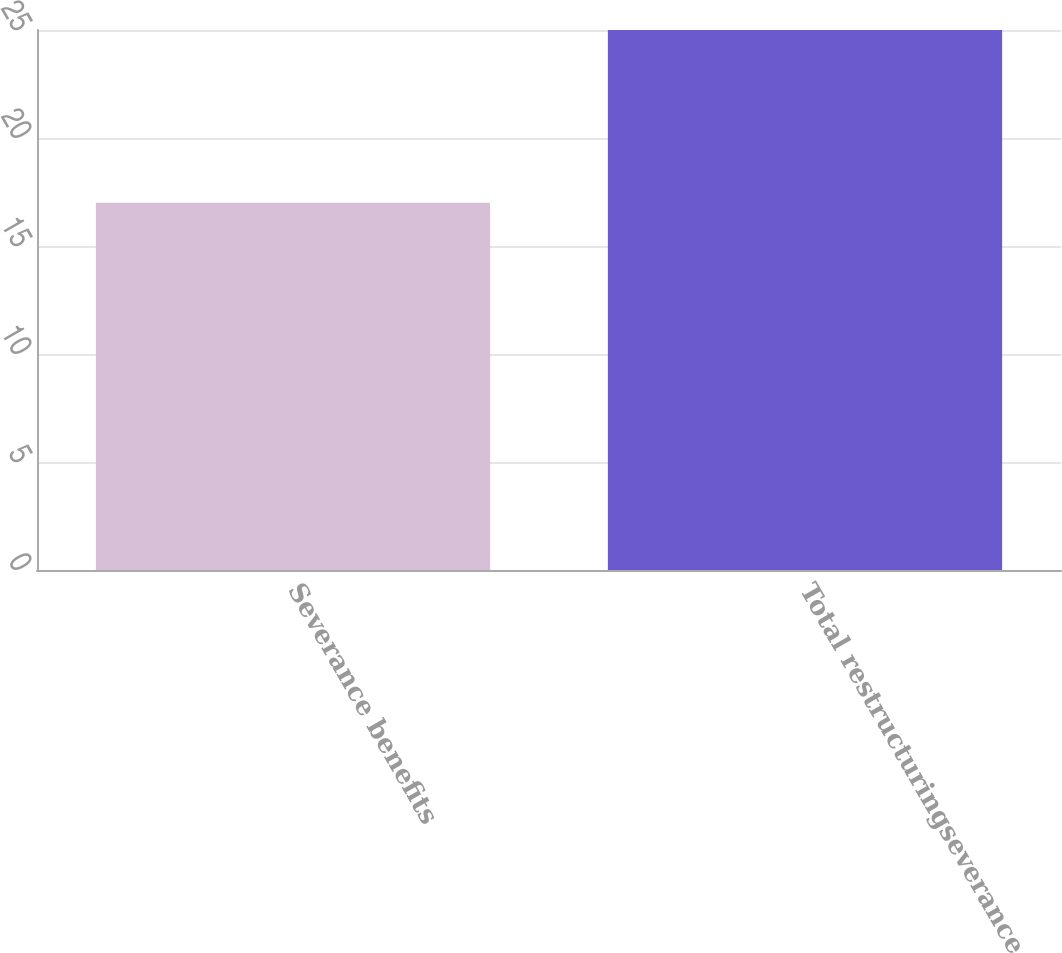Convert chart. <chart><loc_0><loc_0><loc_500><loc_500><bar_chart><fcel>Severance benefits<fcel>Total restructuringseverance<nl><fcel>17<fcel>25<nl></chart> 